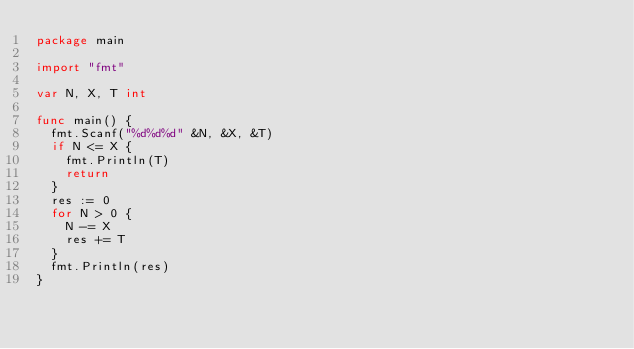Convert code to text. <code><loc_0><loc_0><loc_500><loc_500><_Go_>package main

import "fmt"

var N, X, T int

func main() {
  fmt.Scanf("%d%d%d" &N, &X, &T)
  if N <= X {
    fmt.Println(T)
    return
  }
  res := 0
  for N > 0 {
  	N -= X
    res += T
  }
  fmt.Println(res)
}</code> 